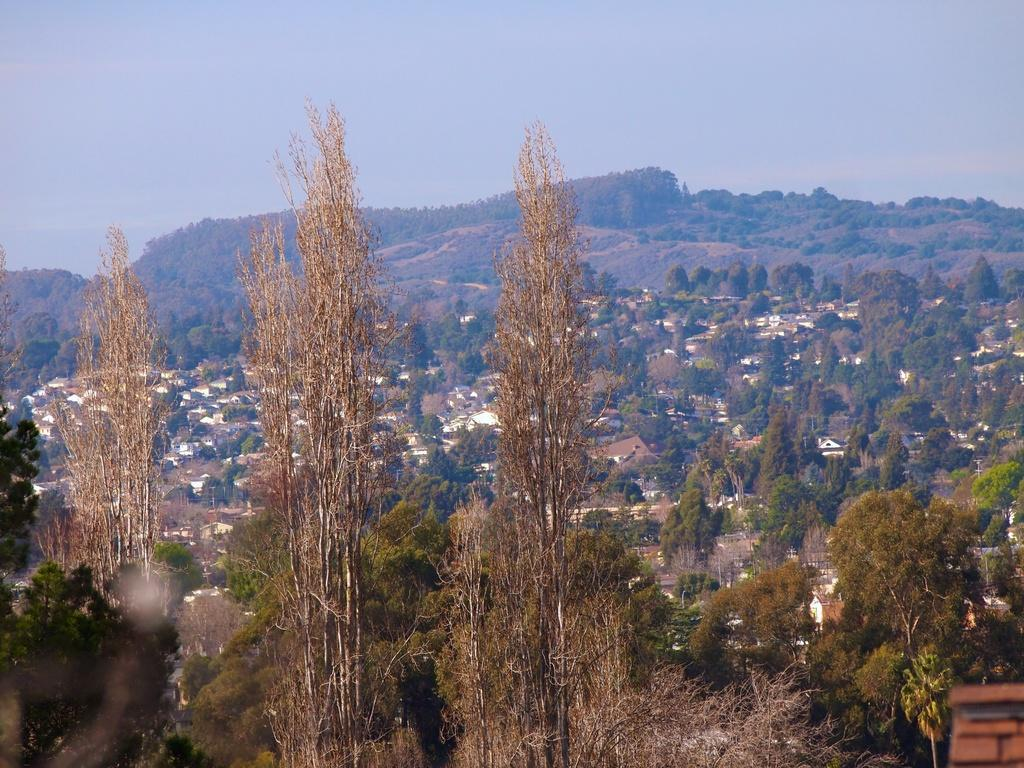What type of vegetation can be seen in the image? There are trees in the image. What geographical feature is located in the middle of the image? There is a hill in the middle of the image. What is visible at the top of the image? The sky is visible at the top of the image. Can you see any nuts or jars in the image? There are no nuts or jars present in the image. How many times does the hill jump in the image? The hill does not jump in the image; it is a stationary geographical feature. 